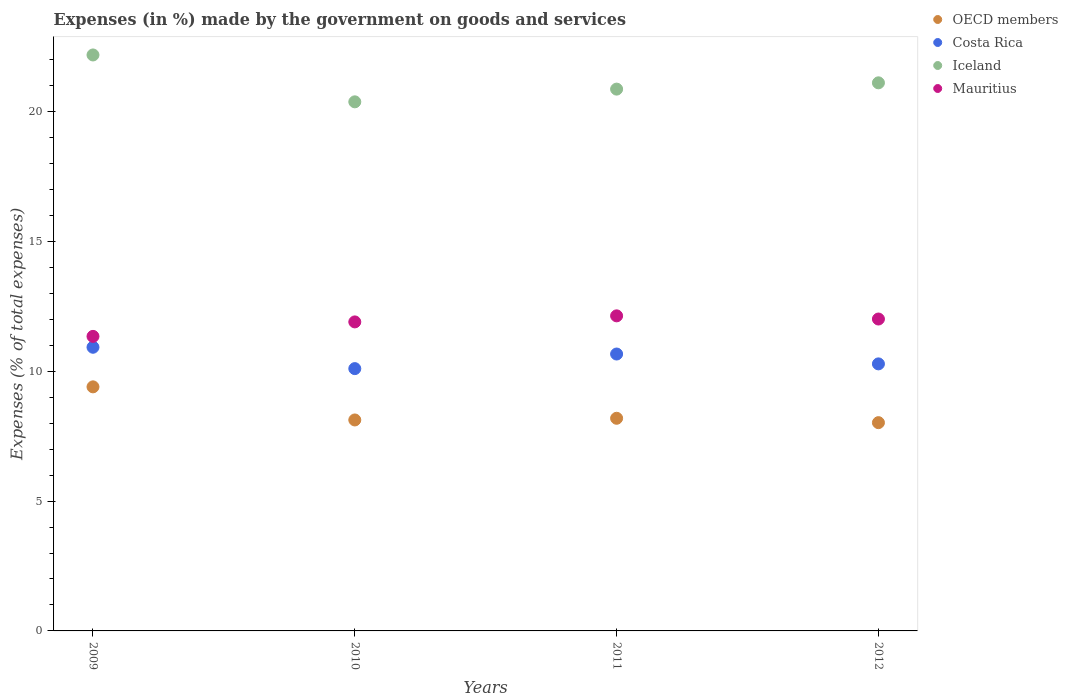What is the percentage of expenses made by the government on goods and services in Mauritius in 2009?
Provide a succinct answer. 11.34. Across all years, what is the maximum percentage of expenses made by the government on goods and services in OECD members?
Your answer should be compact. 9.4. Across all years, what is the minimum percentage of expenses made by the government on goods and services in OECD members?
Your answer should be very brief. 8.02. In which year was the percentage of expenses made by the government on goods and services in Mauritius maximum?
Make the answer very short. 2011. In which year was the percentage of expenses made by the government on goods and services in Costa Rica minimum?
Offer a very short reply. 2010. What is the total percentage of expenses made by the government on goods and services in Iceland in the graph?
Your answer should be very brief. 84.52. What is the difference between the percentage of expenses made by the government on goods and services in OECD members in 2010 and that in 2011?
Keep it short and to the point. -0.06. What is the difference between the percentage of expenses made by the government on goods and services in Iceland in 2011 and the percentage of expenses made by the government on goods and services in Mauritius in 2009?
Provide a succinct answer. 9.52. What is the average percentage of expenses made by the government on goods and services in Costa Rica per year?
Provide a short and direct response. 10.49. In the year 2012, what is the difference between the percentage of expenses made by the government on goods and services in Costa Rica and percentage of expenses made by the government on goods and services in OECD members?
Ensure brevity in your answer.  2.26. In how many years, is the percentage of expenses made by the government on goods and services in Iceland greater than 1 %?
Ensure brevity in your answer.  4. What is the ratio of the percentage of expenses made by the government on goods and services in Costa Rica in 2011 to that in 2012?
Your answer should be compact. 1.04. Is the percentage of expenses made by the government on goods and services in OECD members in 2009 less than that in 2011?
Provide a short and direct response. No. Is the difference between the percentage of expenses made by the government on goods and services in Costa Rica in 2011 and 2012 greater than the difference between the percentage of expenses made by the government on goods and services in OECD members in 2011 and 2012?
Your answer should be very brief. Yes. What is the difference between the highest and the second highest percentage of expenses made by the government on goods and services in Mauritius?
Give a very brief answer. 0.12. What is the difference between the highest and the lowest percentage of expenses made by the government on goods and services in Costa Rica?
Offer a terse response. 0.82. Is it the case that in every year, the sum of the percentage of expenses made by the government on goods and services in Iceland and percentage of expenses made by the government on goods and services in OECD members  is greater than the percentage of expenses made by the government on goods and services in Costa Rica?
Give a very brief answer. Yes. Is the percentage of expenses made by the government on goods and services in Mauritius strictly less than the percentage of expenses made by the government on goods and services in Costa Rica over the years?
Give a very brief answer. No. What is the difference between two consecutive major ticks on the Y-axis?
Your response must be concise. 5. Are the values on the major ticks of Y-axis written in scientific E-notation?
Your answer should be compact. No. Does the graph contain grids?
Your answer should be very brief. No. Where does the legend appear in the graph?
Ensure brevity in your answer.  Top right. What is the title of the graph?
Make the answer very short. Expenses (in %) made by the government on goods and services. Does "Cote d'Ivoire" appear as one of the legend labels in the graph?
Your answer should be compact. No. What is the label or title of the Y-axis?
Keep it short and to the point. Expenses (% of total expenses). What is the Expenses (% of total expenses) in OECD members in 2009?
Your answer should be very brief. 9.4. What is the Expenses (% of total expenses) in Costa Rica in 2009?
Offer a terse response. 10.92. What is the Expenses (% of total expenses) in Iceland in 2009?
Provide a short and direct response. 22.18. What is the Expenses (% of total expenses) of Mauritius in 2009?
Give a very brief answer. 11.34. What is the Expenses (% of total expenses) of OECD members in 2010?
Make the answer very short. 8.12. What is the Expenses (% of total expenses) in Costa Rica in 2010?
Provide a succinct answer. 10.1. What is the Expenses (% of total expenses) in Iceland in 2010?
Offer a very short reply. 20.37. What is the Expenses (% of total expenses) in Mauritius in 2010?
Your answer should be compact. 11.9. What is the Expenses (% of total expenses) in OECD members in 2011?
Make the answer very short. 8.19. What is the Expenses (% of total expenses) in Costa Rica in 2011?
Provide a succinct answer. 10.66. What is the Expenses (% of total expenses) in Iceland in 2011?
Your answer should be compact. 20.86. What is the Expenses (% of total expenses) of Mauritius in 2011?
Give a very brief answer. 12.13. What is the Expenses (% of total expenses) in OECD members in 2012?
Provide a succinct answer. 8.02. What is the Expenses (% of total expenses) in Costa Rica in 2012?
Your answer should be very brief. 10.28. What is the Expenses (% of total expenses) in Iceland in 2012?
Offer a very short reply. 21.11. What is the Expenses (% of total expenses) of Mauritius in 2012?
Ensure brevity in your answer.  12.01. Across all years, what is the maximum Expenses (% of total expenses) in OECD members?
Offer a terse response. 9.4. Across all years, what is the maximum Expenses (% of total expenses) in Costa Rica?
Keep it short and to the point. 10.92. Across all years, what is the maximum Expenses (% of total expenses) in Iceland?
Provide a succinct answer. 22.18. Across all years, what is the maximum Expenses (% of total expenses) in Mauritius?
Provide a succinct answer. 12.13. Across all years, what is the minimum Expenses (% of total expenses) in OECD members?
Keep it short and to the point. 8.02. Across all years, what is the minimum Expenses (% of total expenses) of Costa Rica?
Your answer should be very brief. 10.1. Across all years, what is the minimum Expenses (% of total expenses) in Iceland?
Your answer should be very brief. 20.37. Across all years, what is the minimum Expenses (% of total expenses) in Mauritius?
Give a very brief answer. 11.34. What is the total Expenses (% of total expenses) of OECD members in the graph?
Offer a terse response. 33.73. What is the total Expenses (% of total expenses) in Costa Rica in the graph?
Offer a terse response. 41.97. What is the total Expenses (% of total expenses) of Iceland in the graph?
Offer a terse response. 84.52. What is the total Expenses (% of total expenses) in Mauritius in the graph?
Your response must be concise. 47.38. What is the difference between the Expenses (% of total expenses) of OECD members in 2009 and that in 2010?
Offer a very short reply. 1.27. What is the difference between the Expenses (% of total expenses) of Costa Rica in 2009 and that in 2010?
Provide a succinct answer. 0.82. What is the difference between the Expenses (% of total expenses) of Iceland in 2009 and that in 2010?
Your response must be concise. 1.8. What is the difference between the Expenses (% of total expenses) of Mauritius in 2009 and that in 2010?
Provide a succinct answer. -0.56. What is the difference between the Expenses (% of total expenses) in OECD members in 2009 and that in 2011?
Your response must be concise. 1.21. What is the difference between the Expenses (% of total expenses) of Costa Rica in 2009 and that in 2011?
Ensure brevity in your answer.  0.26. What is the difference between the Expenses (% of total expenses) in Iceland in 2009 and that in 2011?
Offer a terse response. 1.32. What is the difference between the Expenses (% of total expenses) of Mauritius in 2009 and that in 2011?
Give a very brief answer. -0.79. What is the difference between the Expenses (% of total expenses) in OECD members in 2009 and that in 2012?
Offer a very short reply. 1.38. What is the difference between the Expenses (% of total expenses) of Costa Rica in 2009 and that in 2012?
Keep it short and to the point. 0.64. What is the difference between the Expenses (% of total expenses) in Iceland in 2009 and that in 2012?
Provide a short and direct response. 1.07. What is the difference between the Expenses (% of total expenses) of Mauritius in 2009 and that in 2012?
Ensure brevity in your answer.  -0.67. What is the difference between the Expenses (% of total expenses) of OECD members in 2010 and that in 2011?
Make the answer very short. -0.06. What is the difference between the Expenses (% of total expenses) of Costa Rica in 2010 and that in 2011?
Provide a succinct answer. -0.56. What is the difference between the Expenses (% of total expenses) of Iceland in 2010 and that in 2011?
Provide a succinct answer. -0.49. What is the difference between the Expenses (% of total expenses) of Mauritius in 2010 and that in 2011?
Your response must be concise. -0.23. What is the difference between the Expenses (% of total expenses) in OECD members in 2010 and that in 2012?
Ensure brevity in your answer.  0.1. What is the difference between the Expenses (% of total expenses) of Costa Rica in 2010 and that in 2012?
Keep it short and to the point. -0.18. What is the difference between the Expenses (% of total expenses) in Iceland in 2010 and that in 2012?
Your answer should be compact. -0.73. What is the difference between the Expenses (% of total expenses) in Mauritius in 2010 and that in 2012?
Your answer should be compact. -0.11. What is the difference between the Expenses (% of total expenses) of OECD members in 2011 and that in 2012?
Your answer should be compact. 0.17. What is the difference between the Expenses (% of total expenses) of Costa Rica in 2011 and that in 2012?
Ensure brevity in your answer.  0.38. What is the difference between the Expenses (% of total expenses) in Iceland in 2011 and that in 2012?
Offer a terse response. -0.24. What is the difference between the Expenses (% of total expenses) of Mauritius in 2011 and that in 2012?
Ensure brevity in your answer.  0.12. What is the difference between the Expenses (% of total expenses) in OECD members in 2009 and the Expenses (% of total expenses) in Costa Rica in 2010?
Your answer should be very brief. -0.7. What is the difference between the Expenses (% of total expenses) in OECD members in 2009 and the Expenses (% of total expenses) in Iceland in 2010?
Make the answer very short. -10.97. What is the difference between the Expenses (% of total expenses) of OECD members in 2009 and the Expenses (% of total expenses) of Mauritius in 2010?
Provide a succinct answer. -2.5. What is the difference between the Expenses (% of total expenses) of Costa Rica in 2009 and the Expenses (% of total expenses) of Iceland in 2010?
Offer a terse response. -9.45. What is the difference between the Expenses (% of total expenses) in Costa Rica in 2009 and the Expenses (% of total expenses) in Mauritius in 2010?
Your response must be concise. -0.98. What is the difference between the Expenses (% of total expenses) of Iceland in 2009 and the Expenses (% of total expenses) of Mauritius in 2010?
Offer a terse response. 10.28. What is the difference between the Expenses (% of total expenses) of OECD members in 2009 and the Expenses (% of total expenses) of Costa Rica in 2011?
Ensure brevity in your answer.  -1.26. What is the difference between the Expenses (% of total expenses) of OECD members in 2009 and the Expenses (% of total expenses) of Iceland in 2011?
Keep it short and to the point. -11.46. What is the difference between the Expenses (% of total expenses) of OECD members in 2009 and the Expenses (% of total expenses) of Mauritius in 2011?
Your response must be concise. -2.73. What is the difference between the Expenses (% of total expenses) in Costa Rica in 2009 and the Expenses (% of total expenses) in Iceland in 2011?
Provide a short and direct response. -9.94. What is the difference between the Expenses (% of total expenses) in Costa Rica in 2009 and the Expenses (% of total expenses) in Mauritius in 2011?
Provide a succinct answer. -1.21. What is the difference between the Expenses (% of total expenses) of Iceland in 2009 and the Expenses (% of total expenses) of Mauritius in 2011?
Provide a short and direct response. 10.05. What is the difference between the Expenses (% of total expenses) of OECD members in 2009 and the Expenses (% of total expenses) of Costa Rica in 2012?
Provide a short and direct response. -0.88. What is the difference between the Expenses (% of total expenses) in OECD members in 2009 and the Expenses (% of total expenses) in Iceland in 2012?
Keep it short and to the point. -11.71. What is the difference between the Expenses (% of total expenses) of OECD members in 2009 and the Expenses (% of total expenses) of Mauritius in 2012?
Keep it short and to the point. -2.61. What is the difference between the Expenses (% of total expenses) in Costa Rica in 2009 and the Expenses (% of total expenses) in Iceland in 2012?
Provide a short and direct response. -10.18. What is the difference between the Expenses (% of total expenses) in Costa Rica in 2009 and the Expenses (% of total expenses) in Mauritius in 2012?
Ensure brevity in your answer.  -1.09. What is the difference between the Expenses (% of total expenses) in Iceland in 2009 and the Expenses (% of total expenses) in Mauritius in 2012?
Your answer should be compact. 10.17. What is the difference between the Expenses (% of total expenses) of OECD members in 2010 and the Expenses (% of total expenses) of Costa Rica in 2011?
Offer a terse response. -2.54. What is the difference between the Expenses (% of total expenses) in OECD members in 2010 and the Expenses (% of total expenses) in Iceland in 2011?
Offer a very short reply. -12.74. What is the difference between the Expenses (% of total expenses) of OECD members in 2010 and the Expenses (% of total expenses) of Mauritius in 2011?
Offer a terse response. -4.01. What is the difference between the Expenses (% of total expenses) in Costa Rica in 2010 and the Expenses (% of total expenses) in Iceland in 2011?
Offer a terse response. -10.76. What is the difference between the Expenses (% of total expenses) in Costa Rica in 2010 and the Expenses (% of total expenses) in Mauritius in 2011?
Give a very brief answer. -2.03. What is the difference between the Expenses (% of total expenses) in Iceland in 2010 and the Expenses (% of total expenses) in Mauritius in 2011?
Offer a very short reply. 8.24. What is the difference between the Expenses (% of total expenses) of OECD members in 2010 and the Expenses (% of total expenses) of Costa Rica in 2012?
Offer a terse response. -2.16. What is the difference between the Expenses (% of total expenses) of OECD members in 2010 and the Expenses (% of total expenses) of Iceland in 2012?
Give a very brief answer. -12.98. What is the difference between the Expenses (% of total expenses) in OECD members in 2010 and the Expenses (% of total expenses) in Mauritius in 2012?
Your response must be concise. -3.89. What is the difference between the Expenses (% of total expenses) of Costa Rica in 2010 and the Expenses (% of total expenses) of Iceland in 2012?
Provide a short and direct response. -11. What is the difference between the Expenses (% of total expenses) in Costa Rica in 2010 and the Expenses (% of total expenses) in Mauritius in 2012?
Provide a short and direct response. -1.91. What is the difference between the Expenses (% of total expenses) of Iceland in 2010 and the Expenses (% of total expenses) of Mauritius in 2012?
Your response must be concise. 8.36. What is the difference between the Expenses (% of total expenses) in OECD members in 2011 and the Expenses (% of total expenses) in Costa Rica in 2012?
Provide a short and direct response. -2.09. What is the difference between the Expenses (% of total expenses) in OECD members in 2011 and the Expenses (% of total expenses) in Iceland in 2012?
Keep it short and to the point. -12.92. What is the difference between the Expenses (% of total expenses) in OECD members in 2011 and the Expenses (% of total expenses) in Mauritius in 2012?
Keep it short and to the point. -3.82. What is the difference between the Expenses (% of total expenses) in Costa Rica in 2011 and the Expenses (% of total expenses) in Iceland in 2012?
Keep it short and to the point. -10.44. What is the difference between the Expenses (% of total expenses) of Costa Rica in 2011 and the Expenses (% of total expenses) of Mauritius in 2012?
Provide a short and direct response. -1.35. What is the difference between the Expenses (% of total expenses) of Iceland in 2011 and the Expenses (% of total expenses) of Mauritius in 2012?
Offer a terse response. 8.85. What is the average Expenses (% of total expenses) in OECD members per year?
Provide a short and direct response. 8.43. What is the average Expenses (% of total expenses) in Costa Rica per year?
Your answer should be very brief. 10.49. What is the average Expenses (% of total expenses) of Iceland per year?
Your answer should be very brief. 21.13. What is the average Expenses (% of total expenses) of Mauritius per year?
Your response must be concise. 11.85. In the year 2009, what is the difference between the Expenses (% of total expenses) in OECD members and Expenses (% of total expenses) in Costa Rica?
Provide a succinct answer. -1.52. In the year 2009, what is the difference between the Expenses (% of total expenses) in OECD members and Expenses (% of total expenses) in Iceland?
Offer a terse response. -12.78. In the year 2009, what is the difference between the Expenses (% of total expenses) of OECD members and Expenses (% of total expenses) of Mauritius?
Provide a short and direct response. -1.94. In the year 2009, what is the difference between the Expenses (% of total expenses) in Costa Rica and Expenses (% of total expenses) in Iceland?
Offer a terse response. -11.26. In the year 2009, what is the difference between the Expenses (% of total expenses) of Costa Rica and Expenses (% of total expenses) of Mauritius?
Your answer should be very brief. -0.42. In the year 2009, what is the difference between the Expenses (% of total expenses) in Iceland and Expenses (% of total expenses) in Mauritius?
Your answer should be very brief. 10.84. In the year 2010, what is the difference between the Expenses (% of total expenses) of OECD members and Expenses (% of total expenses) of Costa Rica?
Keep it short and to the point. -1.98. In the year 2010, what is the difference between the Expenses (% of total expenses) in OECD members and Expenses (% of total expenses) in Iceland?
Provide a succinct answer. -12.25. In the year 2010, what is the difference between the Expenses (% of total expenses) in OECD members and Expenses (% of total expenses) in Mauritius?
Make the answer very short. -3.78. In the year 2010, what is the difference between the Expenses (% of total expenses) of Costa Rica and Expenses (% of total expenses) of Iceland?
Your answer should be very brief. -10.27. In the year 2010, what is the difference between the Expenses (% of total expenses) in Costa Rica and Expenses (% of total expenses) in Mauritius?
Your answer should be very brief. -1.8. In the year 2010, what is the difference between the Expenses (% of total expenses) in Iceland and Expenses (% of total expenses) in Mauritius?
Your response must be concise. 8.47. In the year 2011, what is the difference between the Expenses (% of total expenses) in OECD members and Expenses (% of total expenses) in Costa Rica?
Provide a short and direct response. -2.47. In the year 2011, what is the difference between the Expenses (% of total expenses) in OECD members and Expenses (% of total expenses) in Iceland?
Your answer should be compact. -12.67. In the year 2011, what is the difference between the Expenses (% of total expenses) of OECD members and Expenses (% of total expenses) of Mauritius?
Offer a terse response. -3.94. In the year 2011, what is the difference between the Expenses (% of total expenses) in Costa Rica and Expenses (% of total expenses) in Iceland?
Provide a succinct answer. -10.2. In the year 2011, what is the difference between the Expenses (% of total expenses) in Costa Rica and Expenses (% of total expenses) in Mauritius?
Make the answer very short. -1.47. In the year 2011, what is the difference between the Expenses (% of total expenses) of Iceland and Expenses (% of total expenses) of Mauritius?
Make the answer very short. 8.73. In the year 2012, what is the difference between the Expenses (% of total expenses) in OECD members and Expenses (% of total expenses) in Costa Rica?
Provide a short and direct response. -2.26. In the year 2012, what is the difference between the Expenses (% of total expenses) in OECD members and Expenses (% of total expenses) in Iceland?
Offer a terse response. -13.09. In the year 2012, what is the difference between the Expenses (% of total expenses) of OECD members and Expenses (% of total expenses) of Mauritius?
Ensure brevity in your answer.  -3.99. In the year 2012, what is the difference between the Expenses (% of total expenses) in Costa Rica and Expenses (% of total expenses) in Iceland?
Your response must be concise. -10.82. In the year 2012, what is the difference between the Expenses (% of total expenses) of Costa Rica and Expenses (% of total expenses) of Mauritius?
Your answer should be very brief. -1.73. In the year 2012, what is the difference between the Expenses (% of total expenses) in Iceland and Expenses (% of total expenses) in Mauritius?
Ensure brevity in your answer.  9.1. What is the ratio of the Expenses (% of total expenses) in OECD members in 2009 to that in 2010?
Provide a short and direct response. 1.16. What is the ratio of the Expenses (% of total expenses) in Costa Rica in 2009 to that in 2010?
Give a very brief answer. 1.08. What is the ratio of the Expenses (% of total expenses) of Iceland in 2009 to that in 2010?
Provide a short and direct response. 1.09. What is the ratio of the Expenses (% of total expenses) in Mauritius in 2009 to that in 2010?
Your response must be concise. 0.95. What is the ratio of the Expenses (% of total expenses) in OECD members in 2009 to that in 2011?
Your answer should be very brief. 1.15. What is the ratio of the Expenses (% of total expenses) in Costa Rica in 2009 to that in 2011?
Give a very brief answer. 1.02. What is the ratio of the Expenses (% of total expenses) of Iceland in 2009 to that in 2011?
Offer a very short reply. 1.06. What is the ratio of the Expenses (% of total expenses) of Mauritius in 2009 to that in 2011?
Your answer should be very brief. 0.93. What is the ratio of the Expenses (% of total expenses) of OECD members in 2009 to that in 2012?
Ensure brevity in your answer.  1.17. What is the ratio of the Expenses (% of total expenses) in Costa Rica in 2009 to that in 2012?
Keep it short and to the point. 1.06. What is the ratio of the Expenses (% of total expenses) in Iceland in 2009 to that in 2012?
Make the answer very short. 1.05. What is the ratio of the Expenses (% of total expenses) in OECD members in 2010 to that in 2011?
Your answer should be very brief. 0.99. What is the ratio of the Expenses (% of total expenses) in Costa Rica in 2010 to that in 2011?
Keep it short and to the point. 0.95. What is the ratio of the Expenses (% of total expenses) in Iceland in 2010 to that in 2011?
Offer a terse response. 0.98. What is the ratio of the Expenses (% of total expenses) in Mauritius in 2010 to that in 2011?
Make the answer very short. 0.98. What is the ratio of the Expenses (% of total expenses) of OECD members in 2010 to that in 2012?
Make the answer very short. 1.01. What is the ratio of the Expenses (% of total expenses) in Costa Rica in 2010 to that in 2012?
Your answer should be very brief. 0.98. What is the ratio of the Expenses (% of total expenses) in Iceland in 2010 to that in 2012?
Keep it short and to the point. 0.97. What is the ratio of the Expenses (% of total expenses) of Costa Rica in 2011 to that in 2012?
Give a very brief answer. 1.04. What is the ratio of the Expenses (% of total expenses) of Iceland in 2011 to that in 2012?
Your answer should be very brief. 0.99. What is the ratio of the Expenses (% of total expenses) in Mauritius in 2011 to that in 2012?
Ensure brevity in your answer.  1.01. What is the difference between the highest and the second highest Expenses (% of total expenses) of OECD members?
Ensure brevity in your answer.  1.21. What is the difference between the highest and the second highest Expenses (% of total expenses) of Costa Rica?
Your answer should be very brief. 0.26. What is the difference between the highest and the second highest Expenses (% of total expenses) in Iceland?
Ensure brevity in your answer.  1.07. What is the difference between the highest and the second highest Expenses (% of total expenses) in Mauritius?
Provide a short and direct response. 0.12. What is the difference between the highest and the lowest Expenses (% of total expenses) of OECD members?
Offer a terse response. 1.38. What is the difference between the highest and the lowest Expenses (% of total expenses) of Costa Rica?
Your response must be concise. 0.82. What is the difference between the highest and the lowest Expenses (% of total expenses) in Iceland?
Offer a terse response. 1.8. What is the difference between the highest and the lowest Expenses (% of total expenses) in Mauritius?
Make the answer very short. 0.79. 